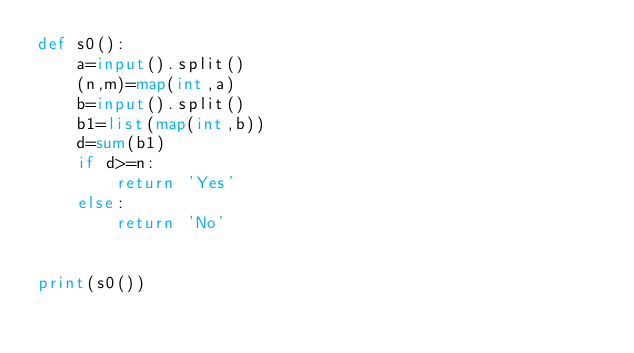Convert code to text. <code><loc_0><loc_0><loc_500><loc_500><_Python_>def s0():
    a=input().split()
    (n,m)=map(int,a)
    b=input().split()
    b1=list(map(int,b))
    d=sum(b1)
    if d>=n:
        return 'Yes'
    else:
        return 'No'


print(s0())</code> 